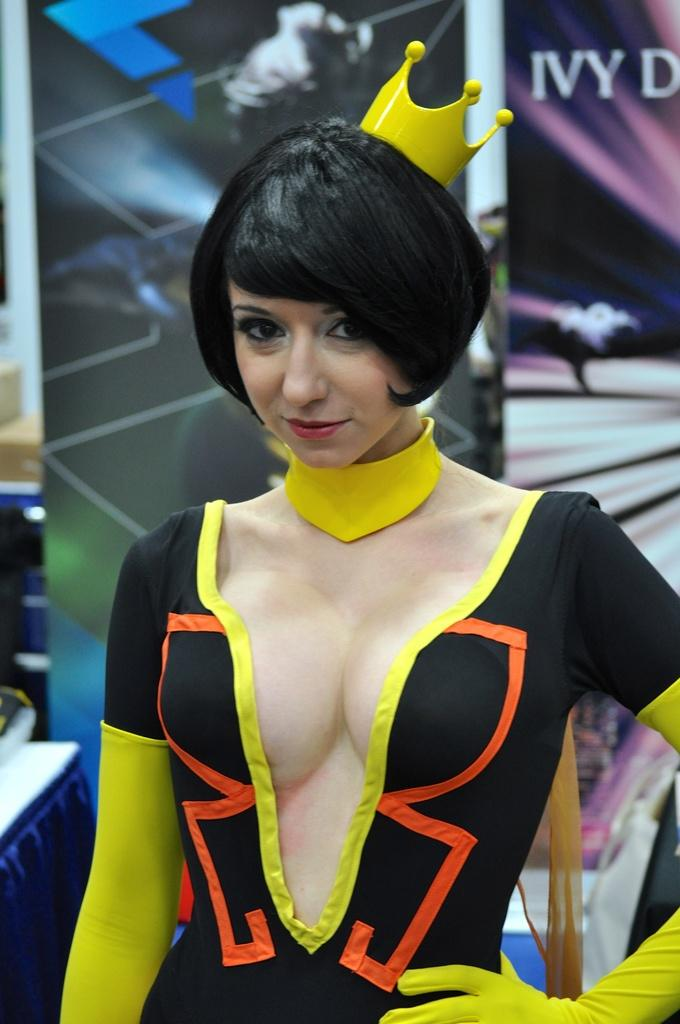Who is present in the image? There is a woman in the image. What is the woman doing in the image? The woman is standing in the image. What is the woman wearing in the image? The woman is wearing a yellow and black dress and a crown in the image. What can be seen in the background of the image? There are banners in the background of the image. What language is the woman speaking in the image? The image does not provide any information about the language being spoken, as there is no audio or text present. 